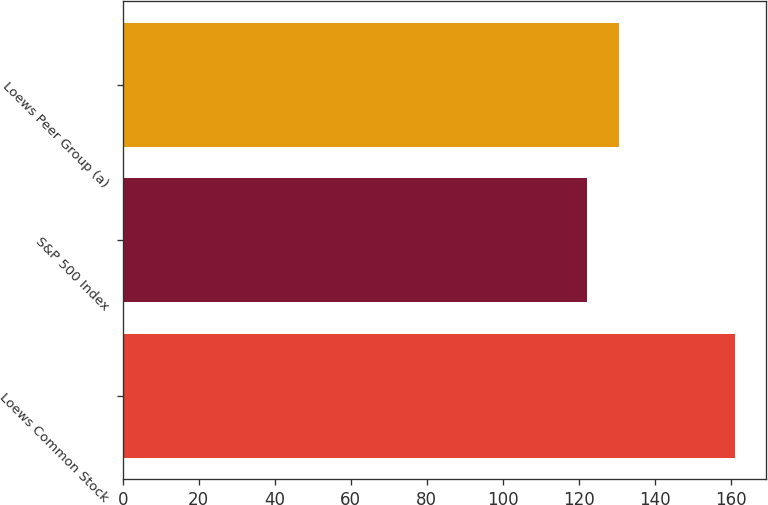<chart> <loc_0><loc_0><loc_500><loc_500><bar_chart><fcel>Loews Common Stock<fcel>S&P 500 Index<fcel>Loews Peer Group (a)<nl><fcel>161.13<fcel>122.16<fcel>130.59<nl></chart> 